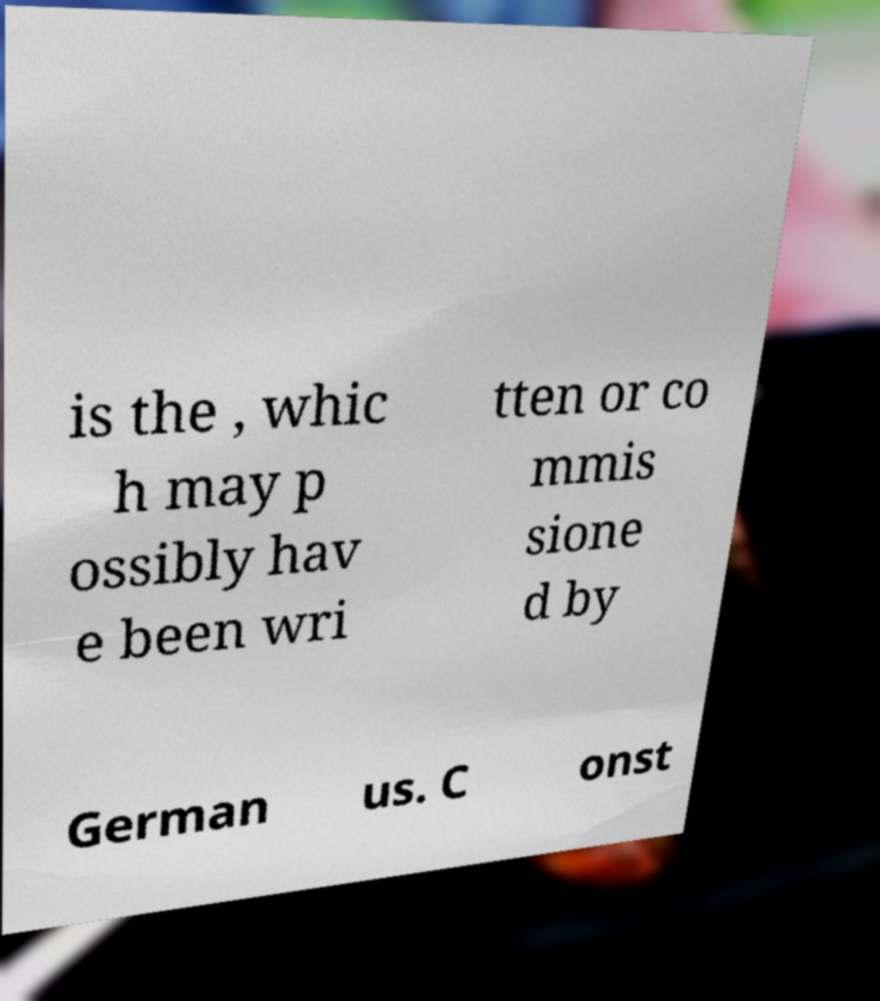Please read and relay the text visible in this image. What does it say? is the , whic h may p ossibly hav e been wri tten or co mmis sione d by German us. C onst 